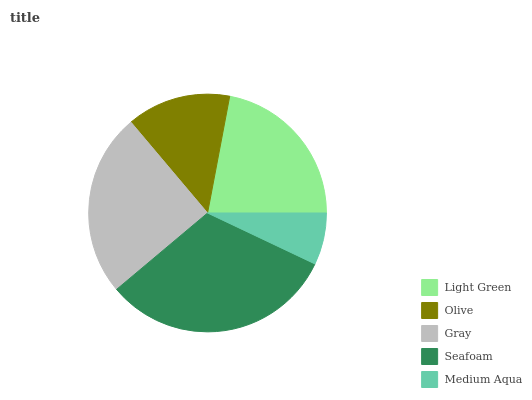Is Medium Aqua the minimum?
Answer yes or no. Yes. Is Seafoam the maximum?
Answer yes or no. Yes. Is Olive the minimum?
Answer yes or no. No. Is Olive the maximum?
Answer yes or no. No. Is Light Green greater than Olive?
Answer yes or no. Yes. Is Olive less than Light Green?
Answer yes or no. Yes. Is Olive greater than Light Green?
Answer yes or no. No. Is Light Green less than Olive?
Answer yes or no. No. Is Light Green the high median?
Answer yes or no. Yes. Is Light Green the low median?
Answer yes or no. Yes. Is Olive the high median?
Answer yes or no. No. Is Olive the low median?
Answer yes or no. No. 